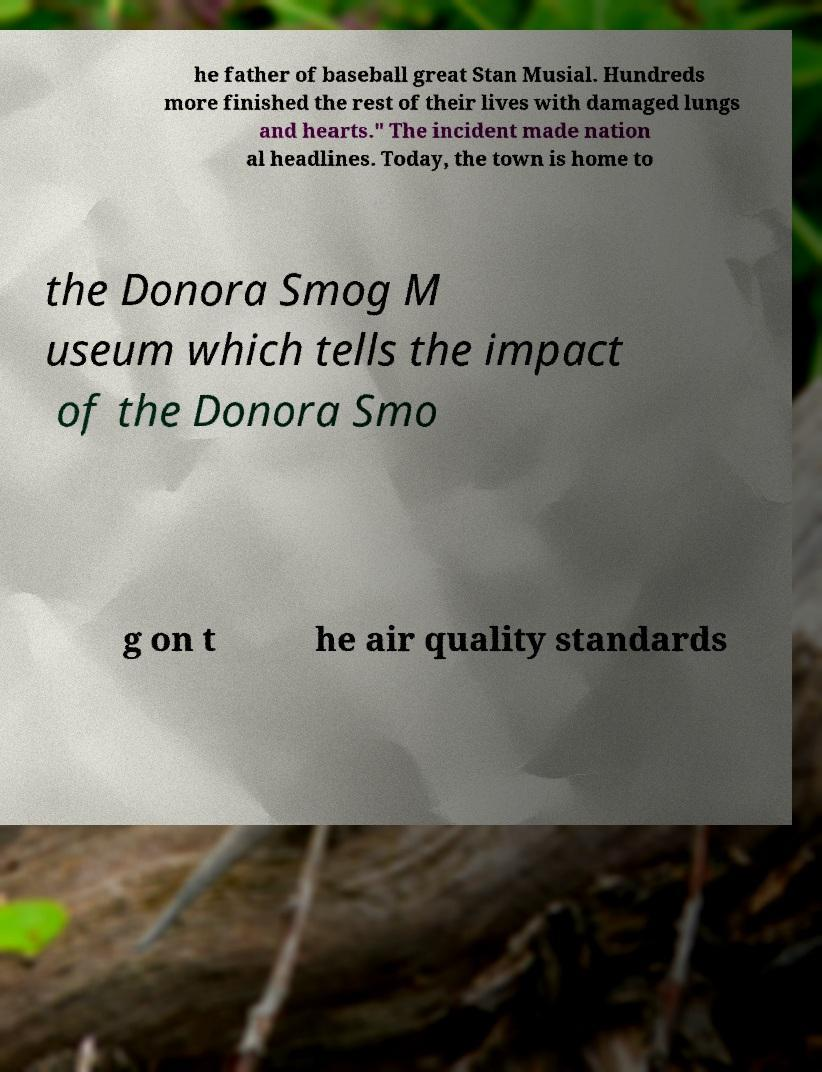Can you read and provide the text displayed in the image?This photo seems to have some interesting text. Can you extract and type it out for me? he father of baseball great Stan Musial. Hundreds more finished the rest of their lives with damaged lungs and hearts." The incident made nation al headlines. Today, the town is home to the Donora Smog M useum which tells the impact of the Donora Smo g on t he air quality standards 